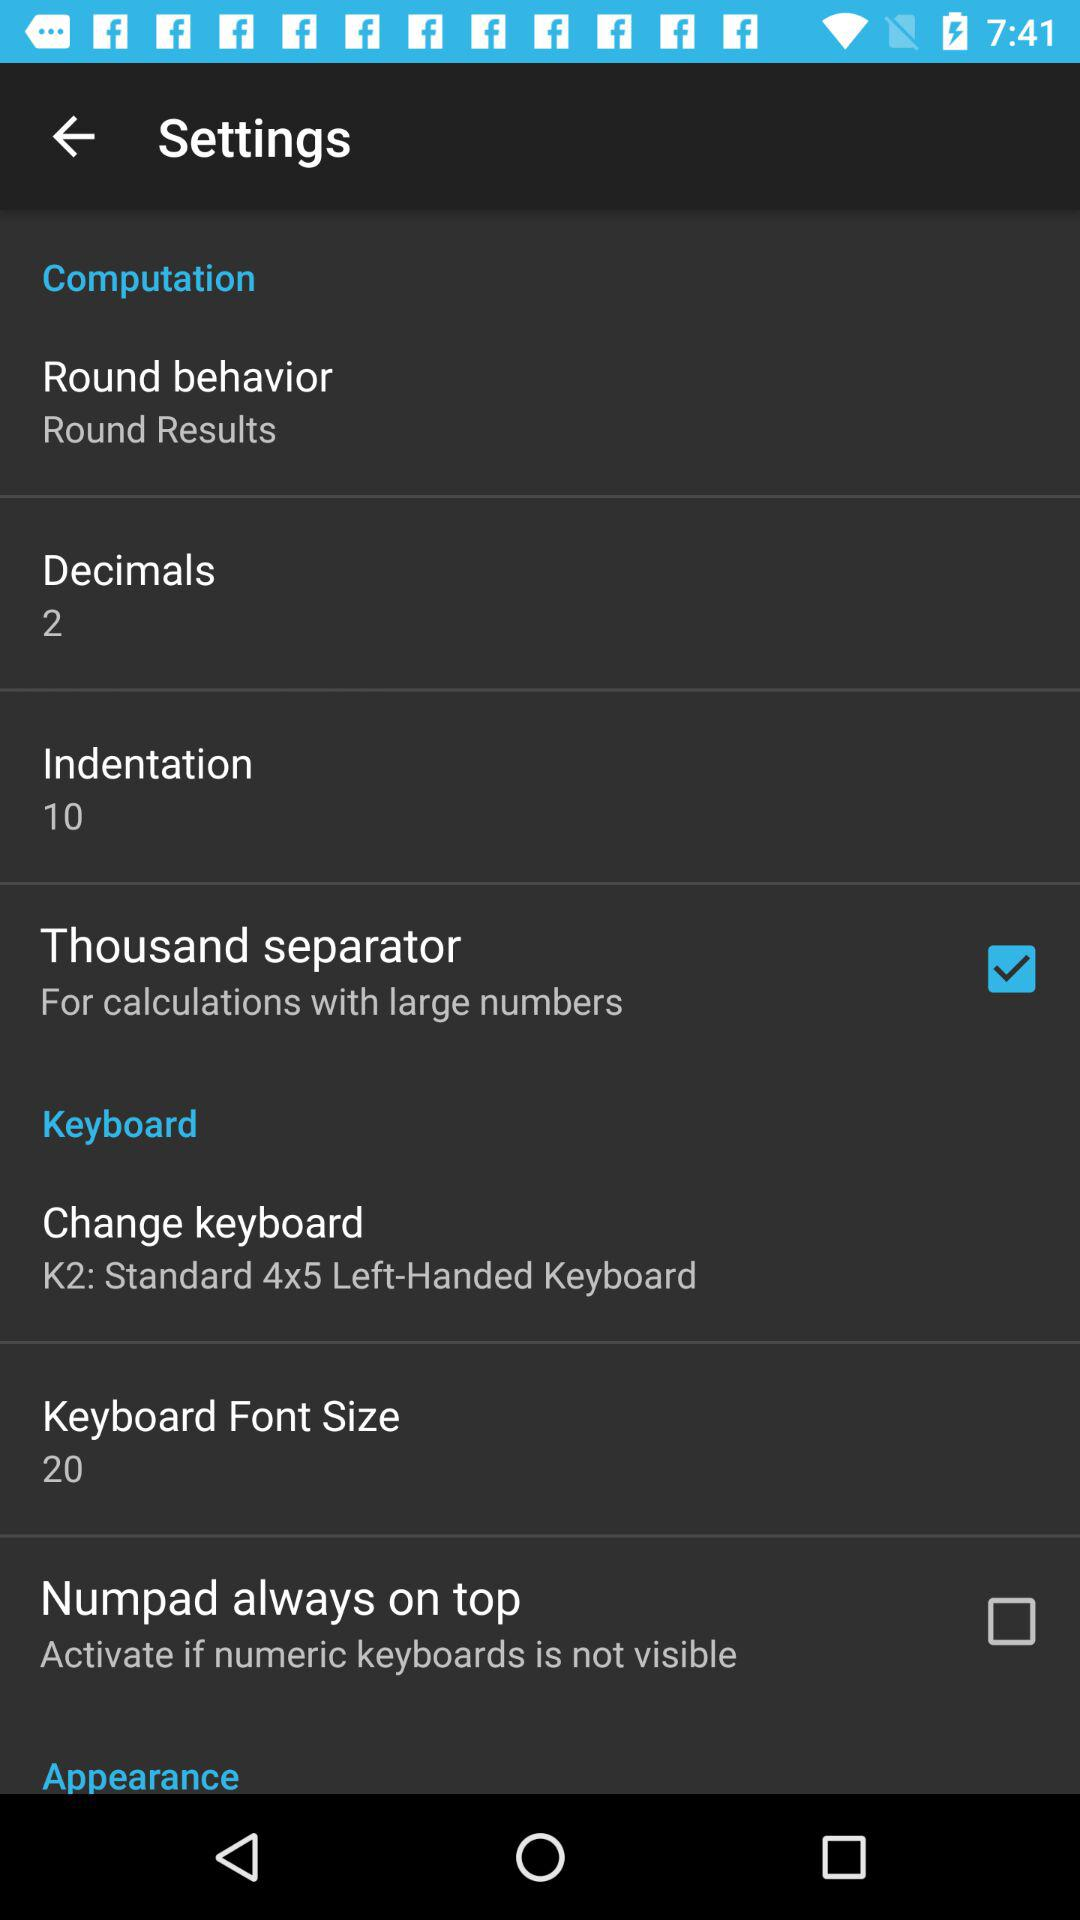What is the keyboard font size? The keyboard font size is 20. 